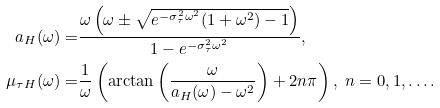<formula> <loc_0><loc_0><loc_500><loc_500>a _ { H } ( \omega ) = & \frac { \omega \left ( \omega \pm \sqrt { e ^ { - \sigma _ { \tau } ^ { 2 } \omega ^ { 2 } } ( 1 + \omega ^ { 2 } ) - 1 } \right ) } { 1 - e ^ { - \sigma _ { \tau } ^ { 2 } \omega ^ { 2 } } } , \\ \mu _ { \tau H } ( \omega ) = & \frac { 1 } { \omega } \left ( \arctan \left ( \frac { \omega } { a _ { H } ( \omega ) - \omega ^ { 2 } } \right ) + 2 n \pi \right ) , \ n = 0 , 1 , \dots .</formula> 